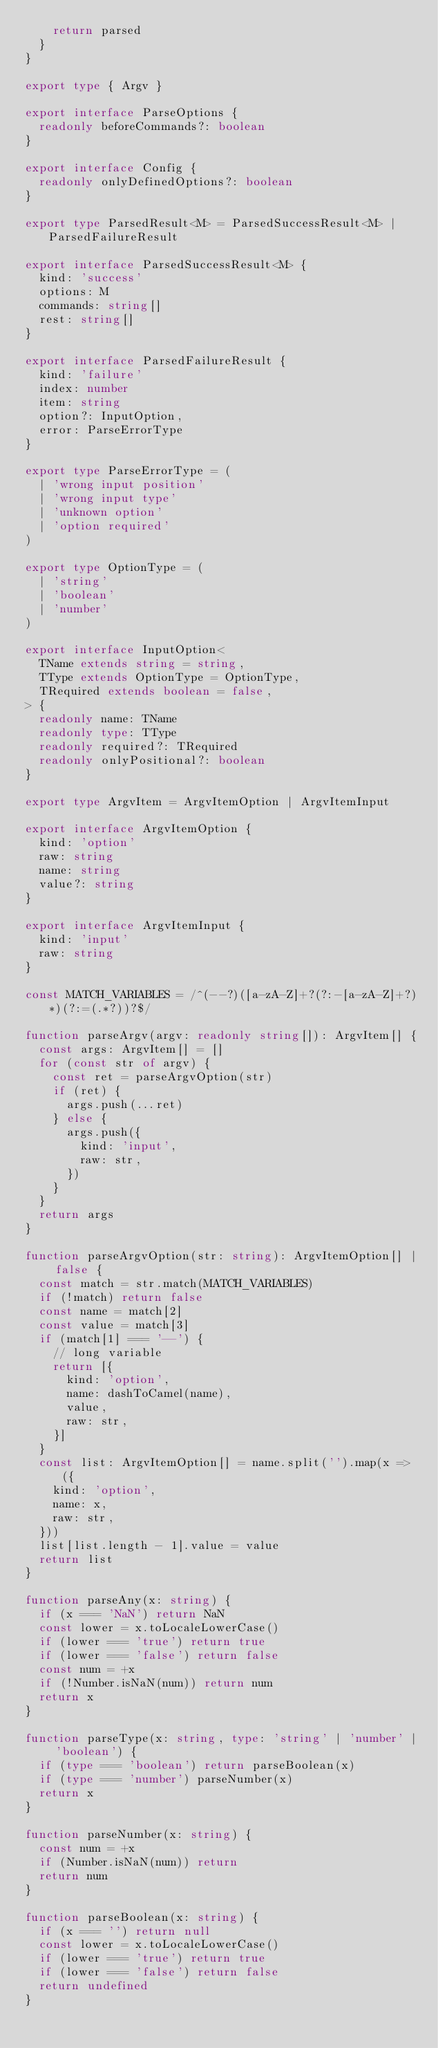Convert code to text. <code><loc_0><loc_0><loc_500><loc_500><_TypeScript_>    return parsed
  }
}

export type { Argv }

export interface ParseOptions {
  readonly beforeCommands?: boolean
}

export interface Config {
  readonly onlyDefinedOptions?: boolean
}

export type ParsedResult<M> = ParsedSuccessResult<M> | ParsedFailureResult

export interface ParsedSuccessResult<M> {
  kind: 'success'
  options: M
  commands: string[]
  rest: string[]
}

export interface ParsedFailureResult {
  kind: 'failure'
  index: number
  item: string
  option?: InputOption,
  error: ParseErrorType
}

export type ParseErrorType = (
  | 'wrong input position'
  | 'wrong input type'
  | 'unknown option'
  | 'option required'
)

export type OptionType = (
  | 'string'
  | 'boolean'
  | 'number'
)

export interface InputOption<
  TName extends string = string,
  TType extends OptionType = OptionType,
  TRequired extends boolean = false,
> {
  readonly name: TName
  readonly type: TType
  readonly required?: TRequired
  readonly onlyPositional?: boolean
}

export type ArgvItem = ArgvItemOption | ArgvItemInput

export interface ArgvItemOption {
  kind: 'option'
  raw: string
  name: string
  value?: string
}

export interface ArgvItemInput {
  kind: 'input'
  raw: string
}

const MATCH_VARIABLES = /^(--?)([a-zA-Z]+?(?:-[a-zA-Z]+?)*)(?:=(.*?))?$/

function parseArgv(argv: readonly string[]): ArgvItem[] {
  const args: ArgvItem[] = []
  for (const str of argv) {
    const ret = parseArgvOption(str)
    if (ret) {
      args.push(...ret)
    } else {
      args.push({
        kind: 'input',
        raw: str,
      })
    }
  }
  return args
}

function parseArgvOption(str: string): ArgvItemOption[] | false {
  const match = str.match(MATCH_VARIABLES)
  if (!match) return false
  const name = match[2]
  const value = match[3]
  if (match[1] === '--') {
    // long variable
    return [{
      kind: 'option',
      name: dashToCamel(name),
      value,
      raw: str,
    }]
  }
  const list: ArgvItemOption[] = name.split('').map(x => ({
    kind: 'option',
    name: x,
    raw: str,
  }))
  list[list.length - 1].value = value
  return list
}

function parseAny(x: string) {
  if (x === 'NaN') return NaN
  const lower = x.toLocaleLowerCase()
  if (lower === 'true') return true
  if (lower === 'false') return false
  const num = +x
  if (!Number.isNaN(num)) return num
  return x
}

function parseType(x: string, type: 'string' | 'number' | 'boolean') {
  if (type === 'boolean') return parseBoolean(x)
  if (type === 'number') parseNumber(x)
  return x
}

function parseNumber(x: string) {
  const num = +x
  if (Number.isNaN(num)) return
  return num
}

function parseBoolean(x: string) {
  if (x === '') return null
  const lower = x.toLocaleLowerCase()
  if (lower === 'true') return true
  if (lower === 'false') return false
  return undefined
}
</code> 